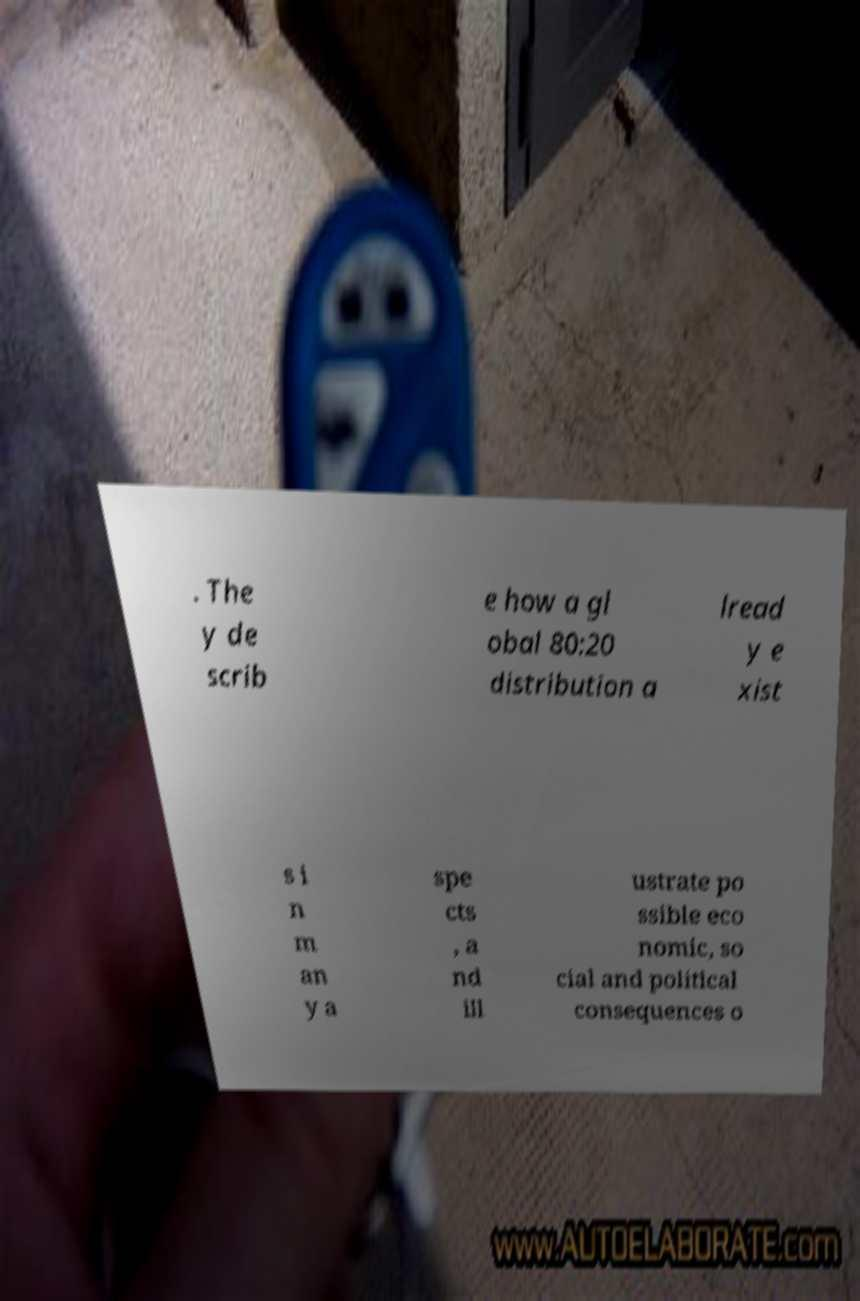Please read and relay the text visible in this image. What does it say? . The y de scrib e how a gl obal 80:20 distribution a lread y e xist s i n m an y a spe cts , a nd ill ustrate po ssible eco nomic, so cial and political consequences o 